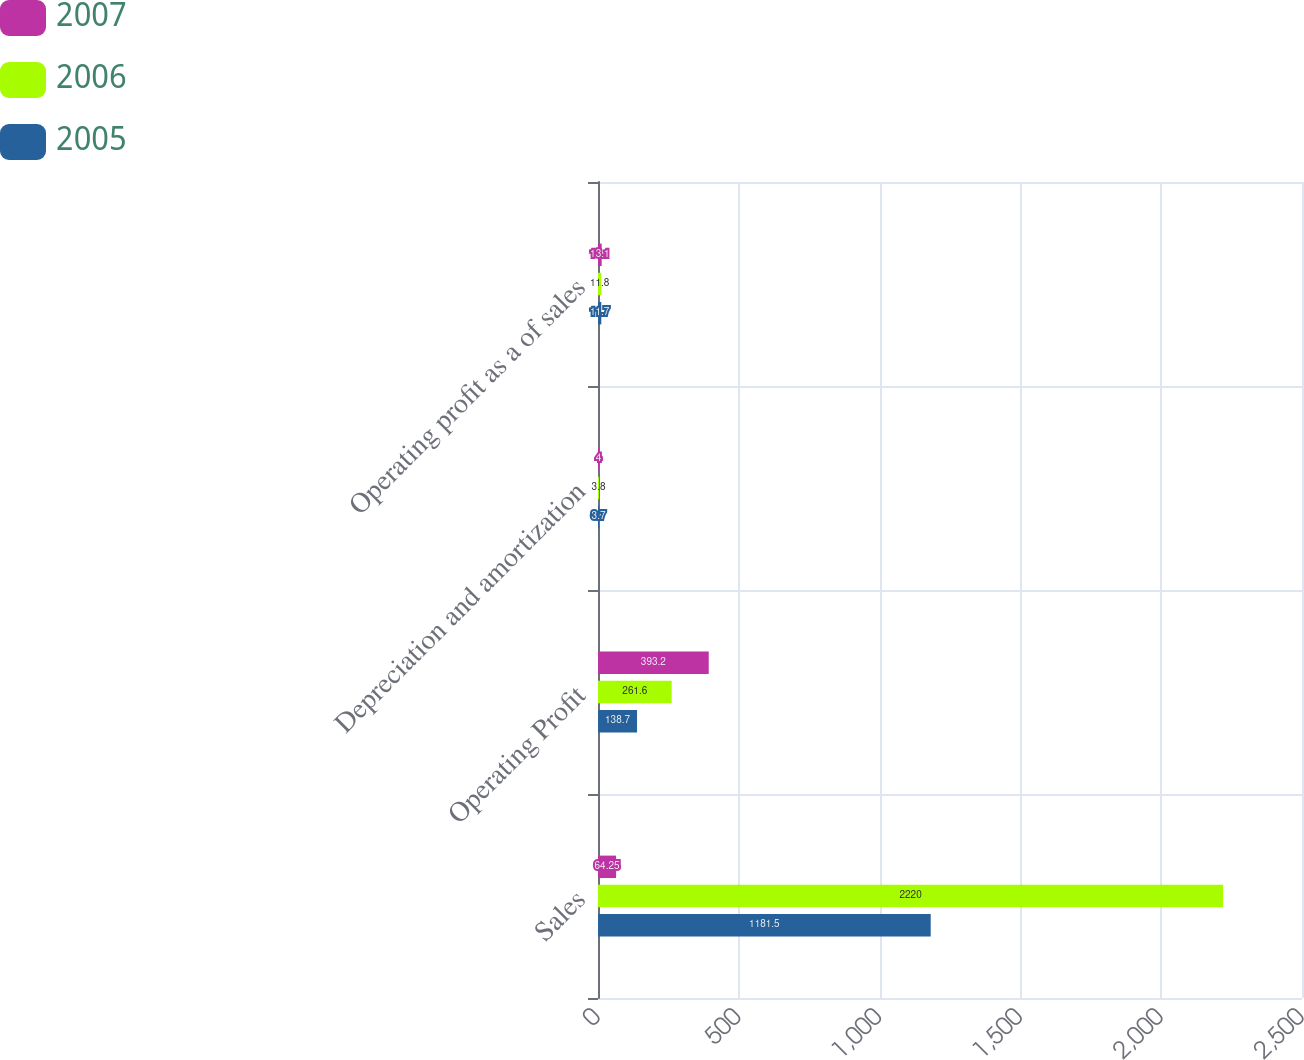<chart> <loc_0><loc_0><loc_500><loc_500><stacked_bar_chart><ecel><fcel>Sales<fcel>Operating Profit<fcel>Depreciation and amortization<fcel>Operating profit as a of sales<nl><fcel>2007<fcel>64.25<fcel>393.2<fcel>4<fcel>13.1<nl><fcel>2006<fcel>2220<fcel>261.6<fcel>3.8<fcel>11.8<nl><fcel>2005<fcel>1181.5<fcel>138.7<fcel>3.7<fcel>11.7<nl></chart> 